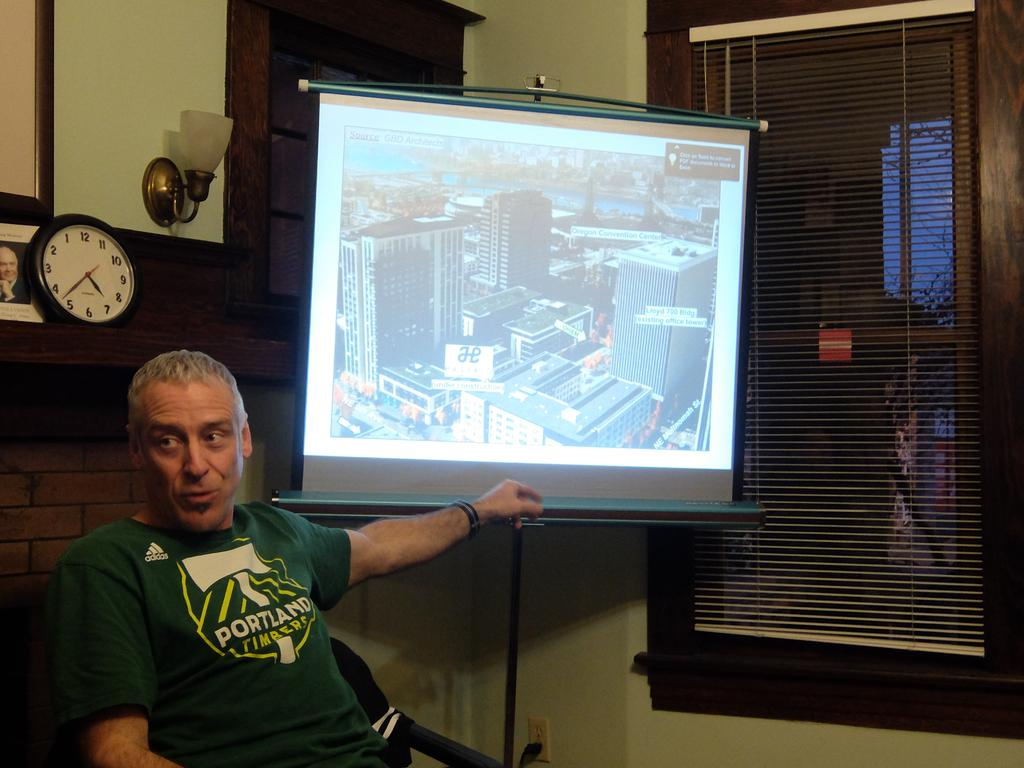<image>
Summarize the visual content of the image. A man in a Portland t-shirt sits near a projection screen and a clock. 